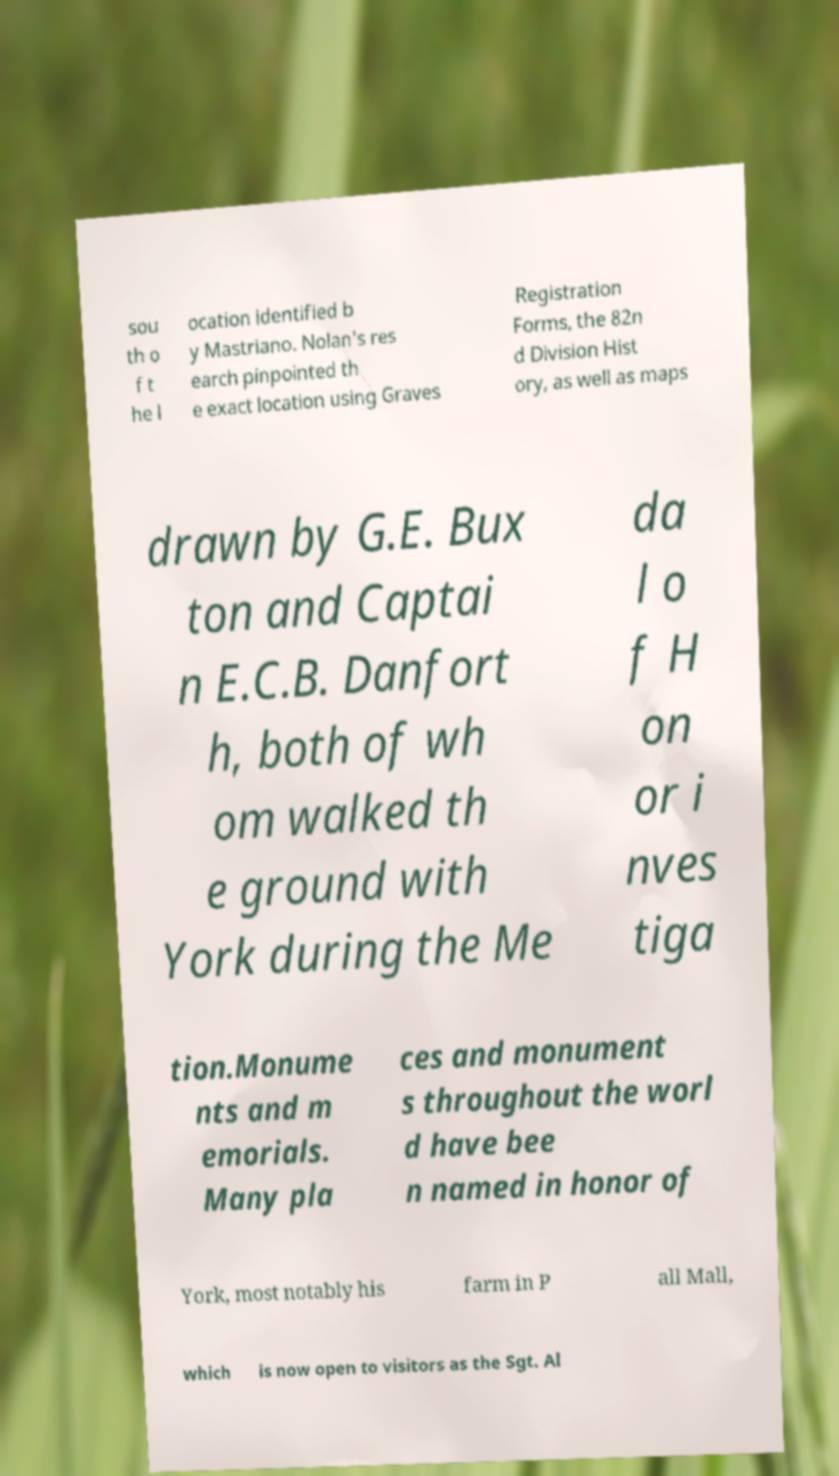I need the written content from this picture converted into text. Can you do that? sou th o f t he l ocation identified b y Mastriano. Nolan's res earch pinpointed th e exact location using Graves Registration Forms, the 82n d Division Hist ory, as well as maps drawn by G.E. Bux ton and Captai n E.C.B. Danfort h, both of wh om walked th e ground with York during the Me da l o f H on or i nves tiga tion.Monume nts and m emorials. Many pla ces and monument s throughout the worl d have bee n named in honor of York, most notably his farm in P all Mall, which is now open to visitors as the Sgt. Al 